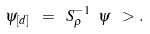<formula> <loc_0><loc_0><loc_500><loc_500>\psi _ { [ d ] } \ = \ S _ { \rho } ^ { - 1 } \ \psi \ > .</formula> 